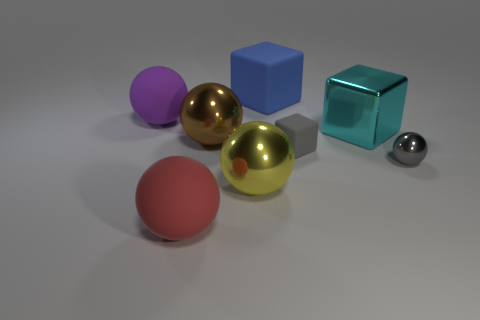Subtract all yellow metal spheres. How many spheres are left? 4 Subtract all red balls. How many balls are left? 4 Add 2 big red things. How many objects exist? 10 Subtract all cyan spheres. Subtract all blue cylinders. How many spheres are left? 5 Subtract all cubes. How many objects are left? 5 Subtract 1 purple balls. How many objects are left? 7 Subtract all tiny gray rubber objects. Subtract all rubber spheres. How many objects are left? 5 Add 1 big rubber objects. How many big rubber objects are left? 4 Add 8 big brown shiny cylinders. How many big brown shiny cylinders exist? 8 